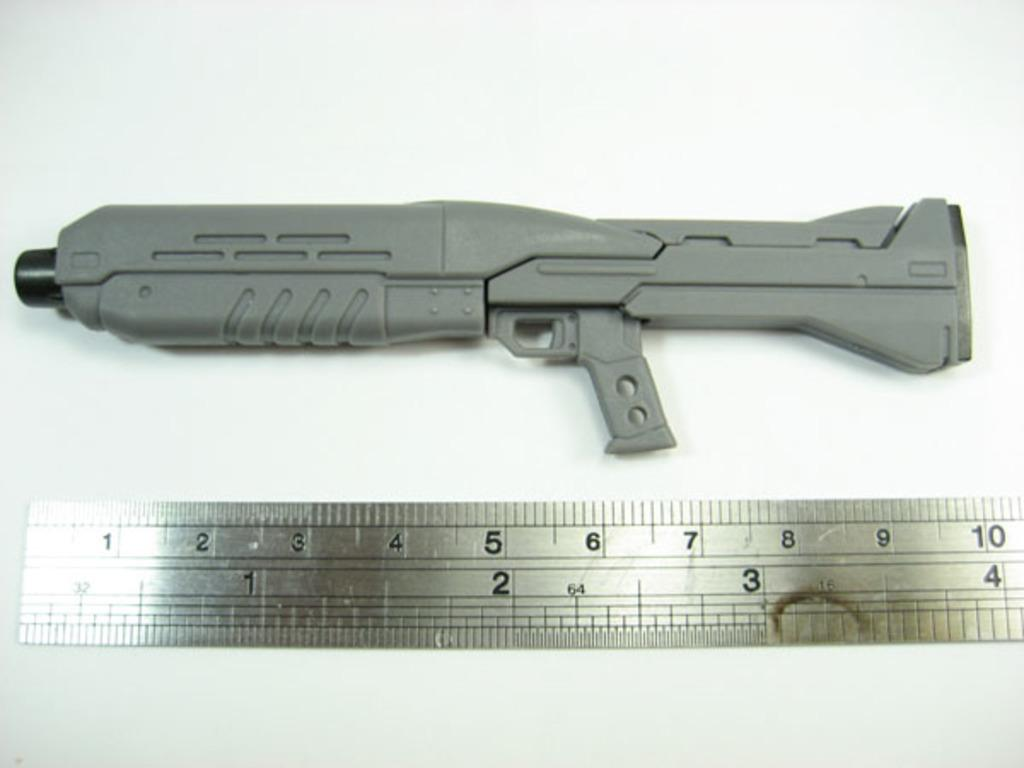<image>
Give a short and clear explanation of the subsequent image. A weapon and a ruler underneath showing that it is 10 inches. 